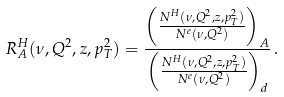Convert formula to latex. <formula><loc_0><loc_0><loc_500><loc_500>R ^ { H } _ { A } ( \nu , Q ^ { 2 } , z , p _ { T } ^ { 2 } ) = \frac { \left ( \frac { N ^ { H } ( \nu , Q ^ { 2 } , z , p _ { T } ^ { 2 } ) } { N ^ { e } ( \nu , Q ^ { 2 } ) } \right ) _ { A } } { \left ( \frac { N ^ { H } ( \nu , Q ^ { 2 } , z , p _ { T } ^ { 2 } ) } { N ^ { e } ( \nu , Q ^ { 2 } ) } \right ) _ { d } } \, .</formula> 